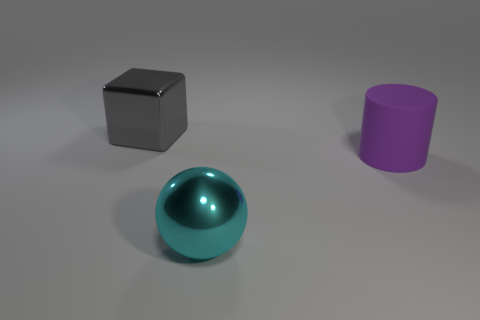Add 1 tiny green balls. How many objects exist? 4 Subtract all balls. How many objects are left? 2 Add 3 large brown objects. How many large brown objects exist? 3 Subtract 0 green spheres. How many objects are left? 3 Subtract all small cyan matte cylinders. Subtract all big shiny things. How many objects are left? 1 Add 2 large metallic blocks. How many large metallic blocks are left? 3 